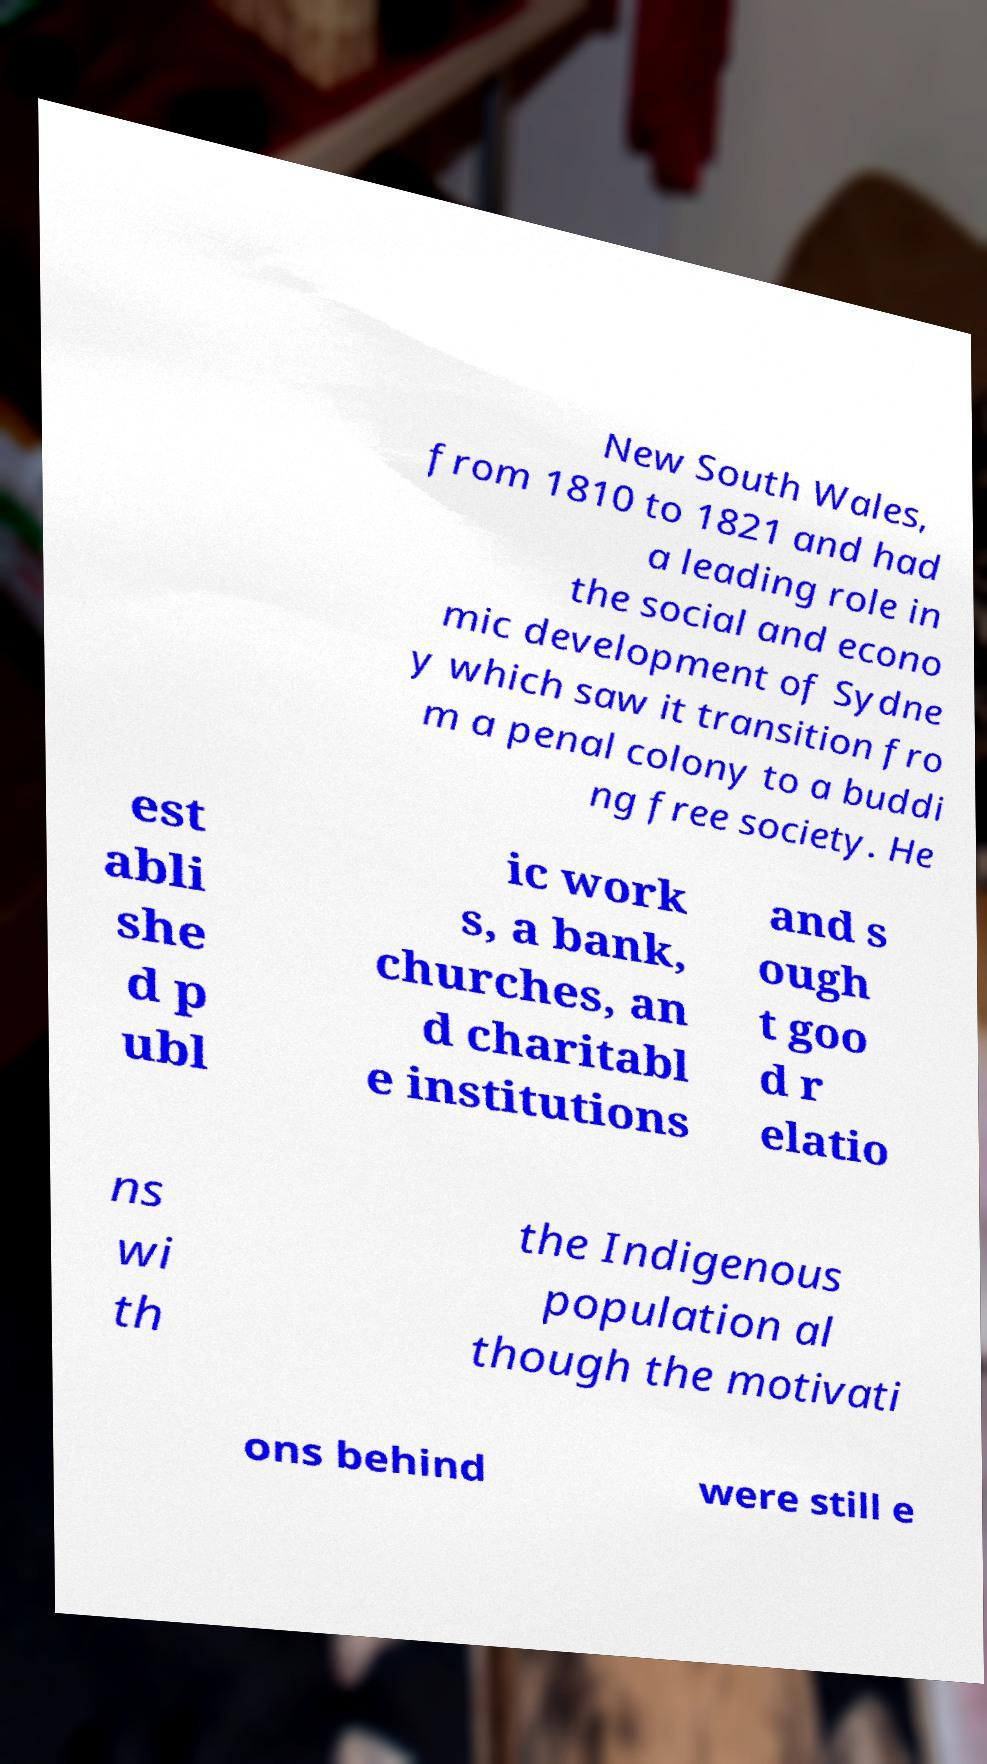For documentation purposes, I need the text within this image transcribed. Could you provide that? New South Wales, from 1810 to 1821 and had a leading role in the social and econo mic development of Sydne y which saw it transition fro m a penal colony to a buddi ng free society. He est abli she d p ubl ic work s, a bank, churches, an d charitabl e institutions and s ough t goo d r elatio ns wi th the Indigenous population al though the motivati ons behind were still e 